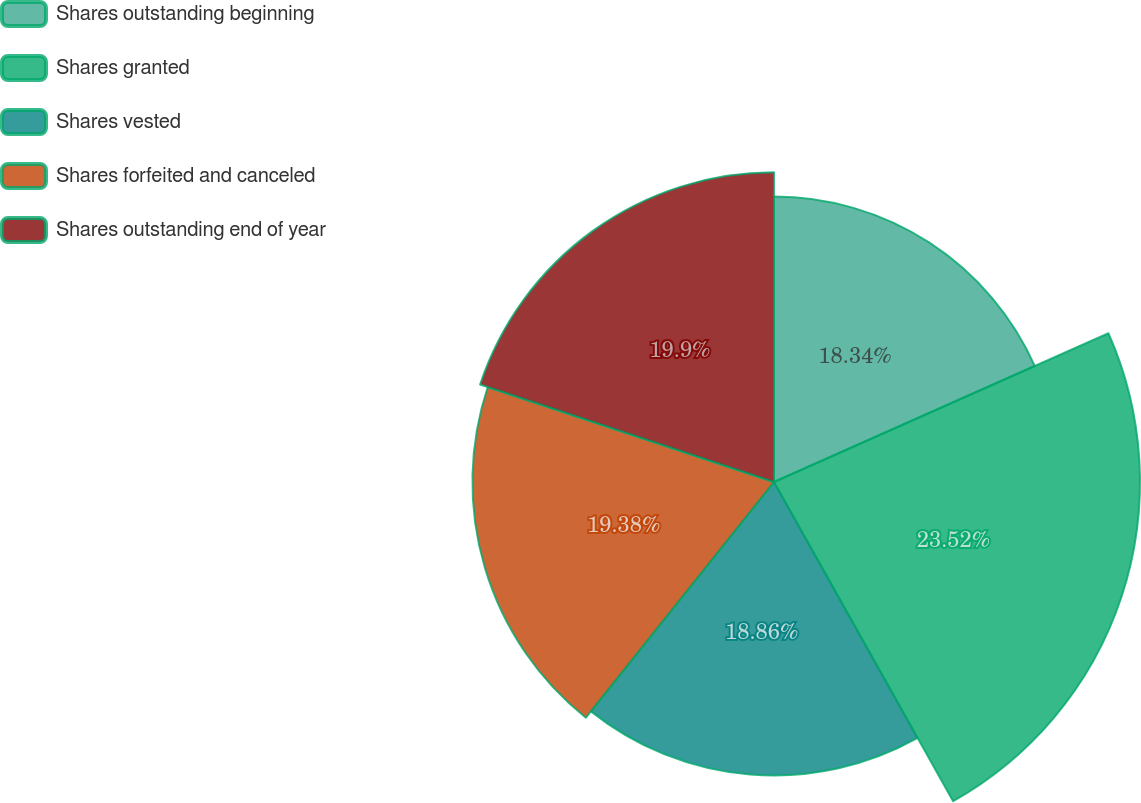Convert chart. <chart><loc_0><loc_0><loc_500><loc_500><pie_chart><fcel>Shares outstanding beginning<fcel>Shares granted<fcel>Shares vested<fcel>Shares forfeited and canceled<fcel>Shares outstanding end of year<nl><fcel>18.34%<fcel>23.52%<fcel>18.86%<fcel>19.38%<fcel>19.9%<nl></chart> 